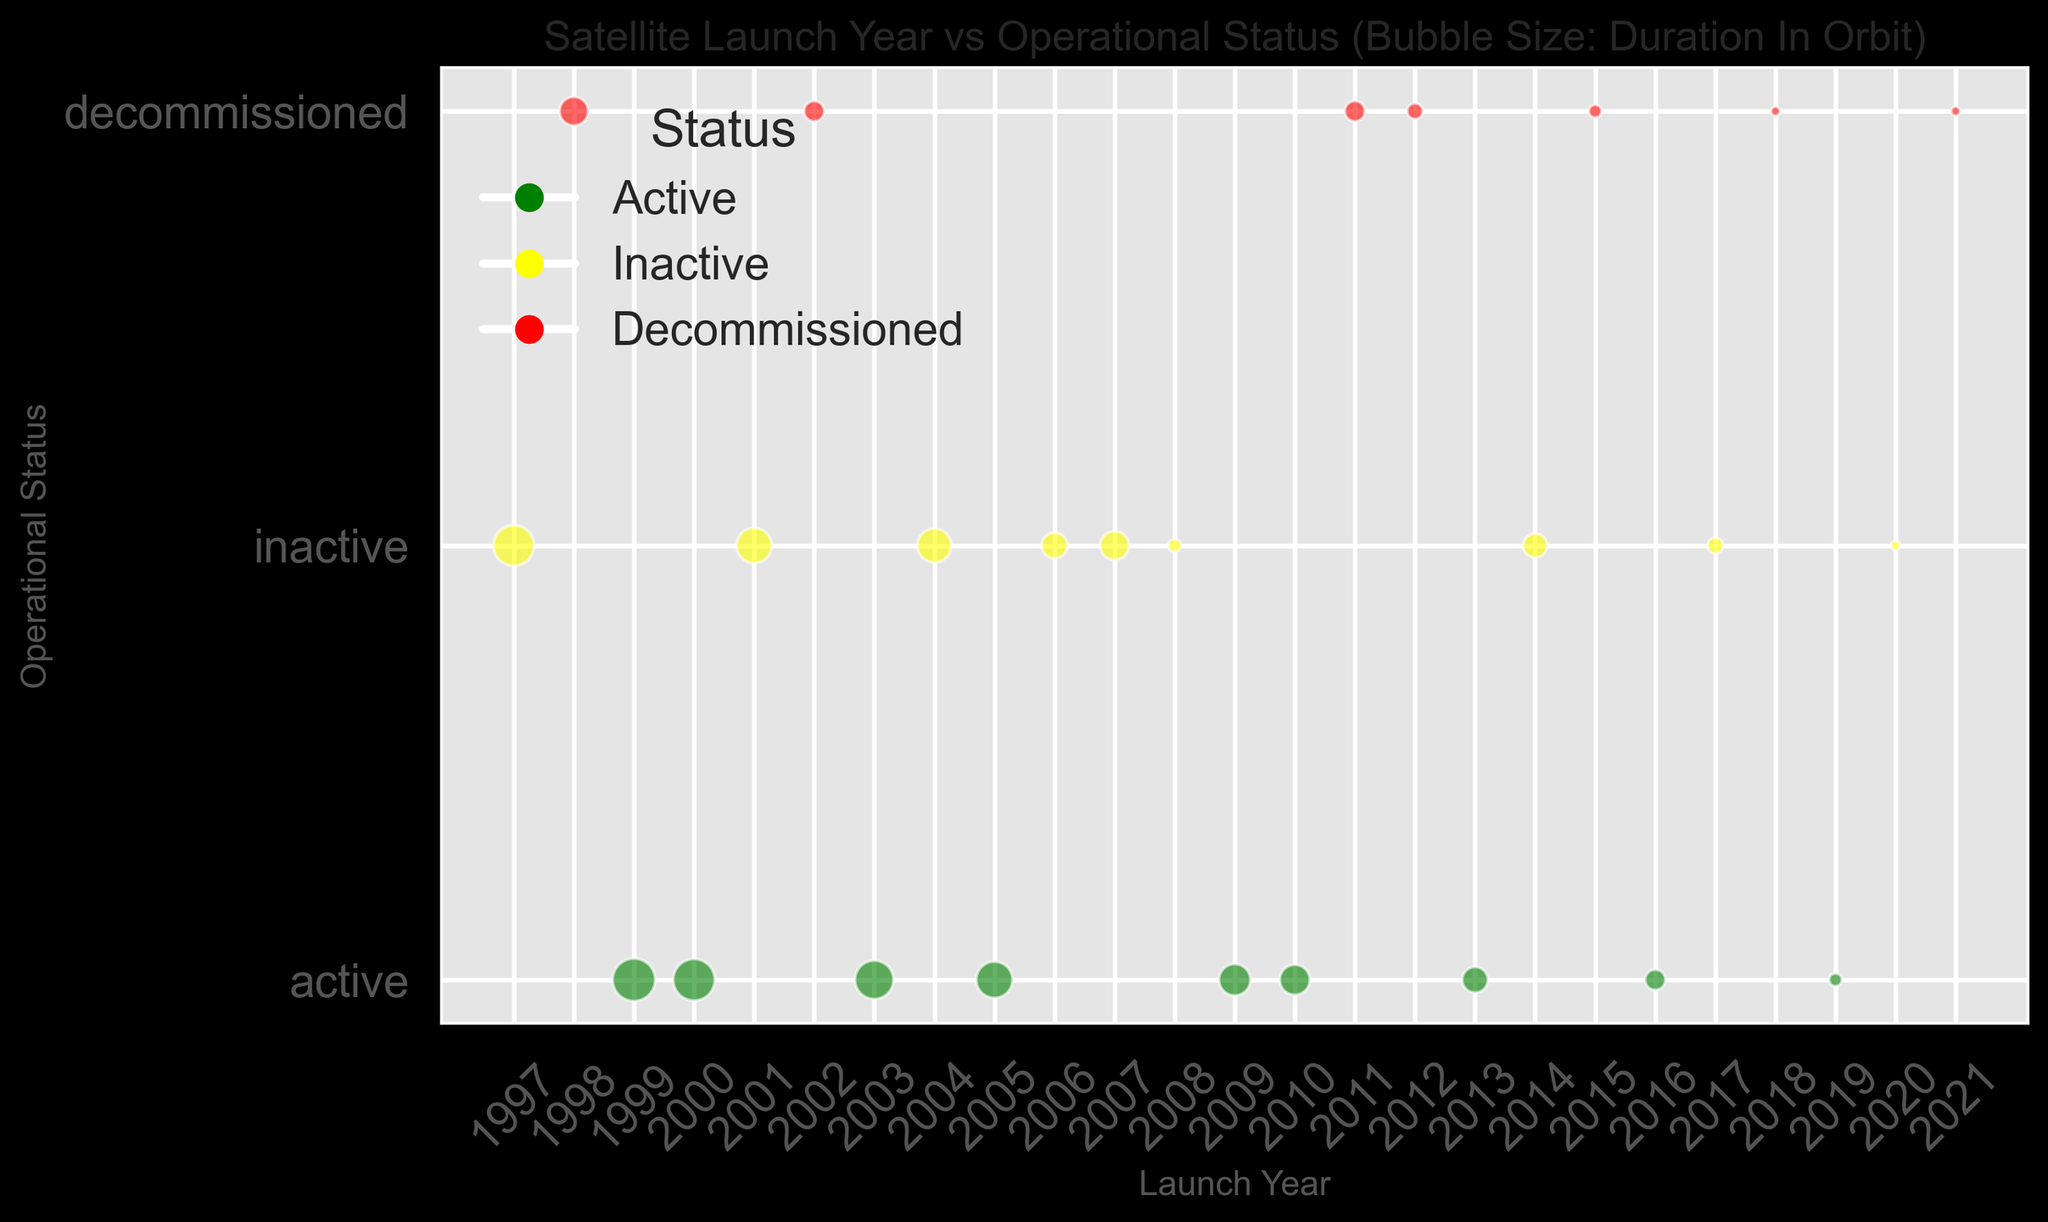What year had the most satellites that are still active? Identify the years in the circles with green color and compare their frequencies. The year 1999 has one of the largest bubbles in green, indicating the longest operational duration.
Answer: 1999 Between 2000 and 2005, how many satellites were decommissioned? Look for red circles within the years 2000 to 2005 on the x-axis. Only the year 2002 has a red circle.
Answer: 1 What is the average duration in orbit for satellites launched in 2014 that are inactive? Identify the year 2014 on the x-axis and locate yellow circles (representing inactive status). Sum the durations of these circles and divide by their count. (7 years)
Answer: 7 Which decommissioned satellite launched in the 2010s had the longest duration in orbit? Look for the largest red circles within the years 2010 to 2019. The year 2011 had a red circle with a duration of 5 years, which is the largest red circle in that range.
Answer: 2011 Compare the number of active satellites launched in 2000 and 2003. Which year had more? Identify the green circles in the years 2000 and 2003. Both years each have one green circle representing active satellites.
Answer: Both are equal What is the combined duration in orbit for all active satellites launched before 2000? Identify all green circles before the year 2000 and sum their durations. Circles for 1999 and 1997 show the durations are 22 and 20 respectively. 22 + 20 = 42
Answer: 42 Which year had more inactive satellites, 2006 or 2014? Identify the yellow circles in the years 2006 and 2014. Both years each have one yellow circle representing inactive satellites.
Answer: Both are equal What is the duration difference between the active satellite launched in 2005 and the inactive one launched in 2007? Identify the sizes of the circles: 2005 (green) = 16 years, 2007 (yellow) = 10 years. Subtract 10 from 16. 16 - 10 = 6
Answer: 6 How many satellites launched in the 2000s are currently decommissioned? Identify all red circles within the years 2000 to 2009. The years 2002 and 2011 each has a red circle.
Answer: 2 Which operational status has the most satellites launched in the year 2012? Identify the circles for the year 2012 and note the color. The circle in 2012 is red, representing decommissioned status.
Answer: Decommissioned 